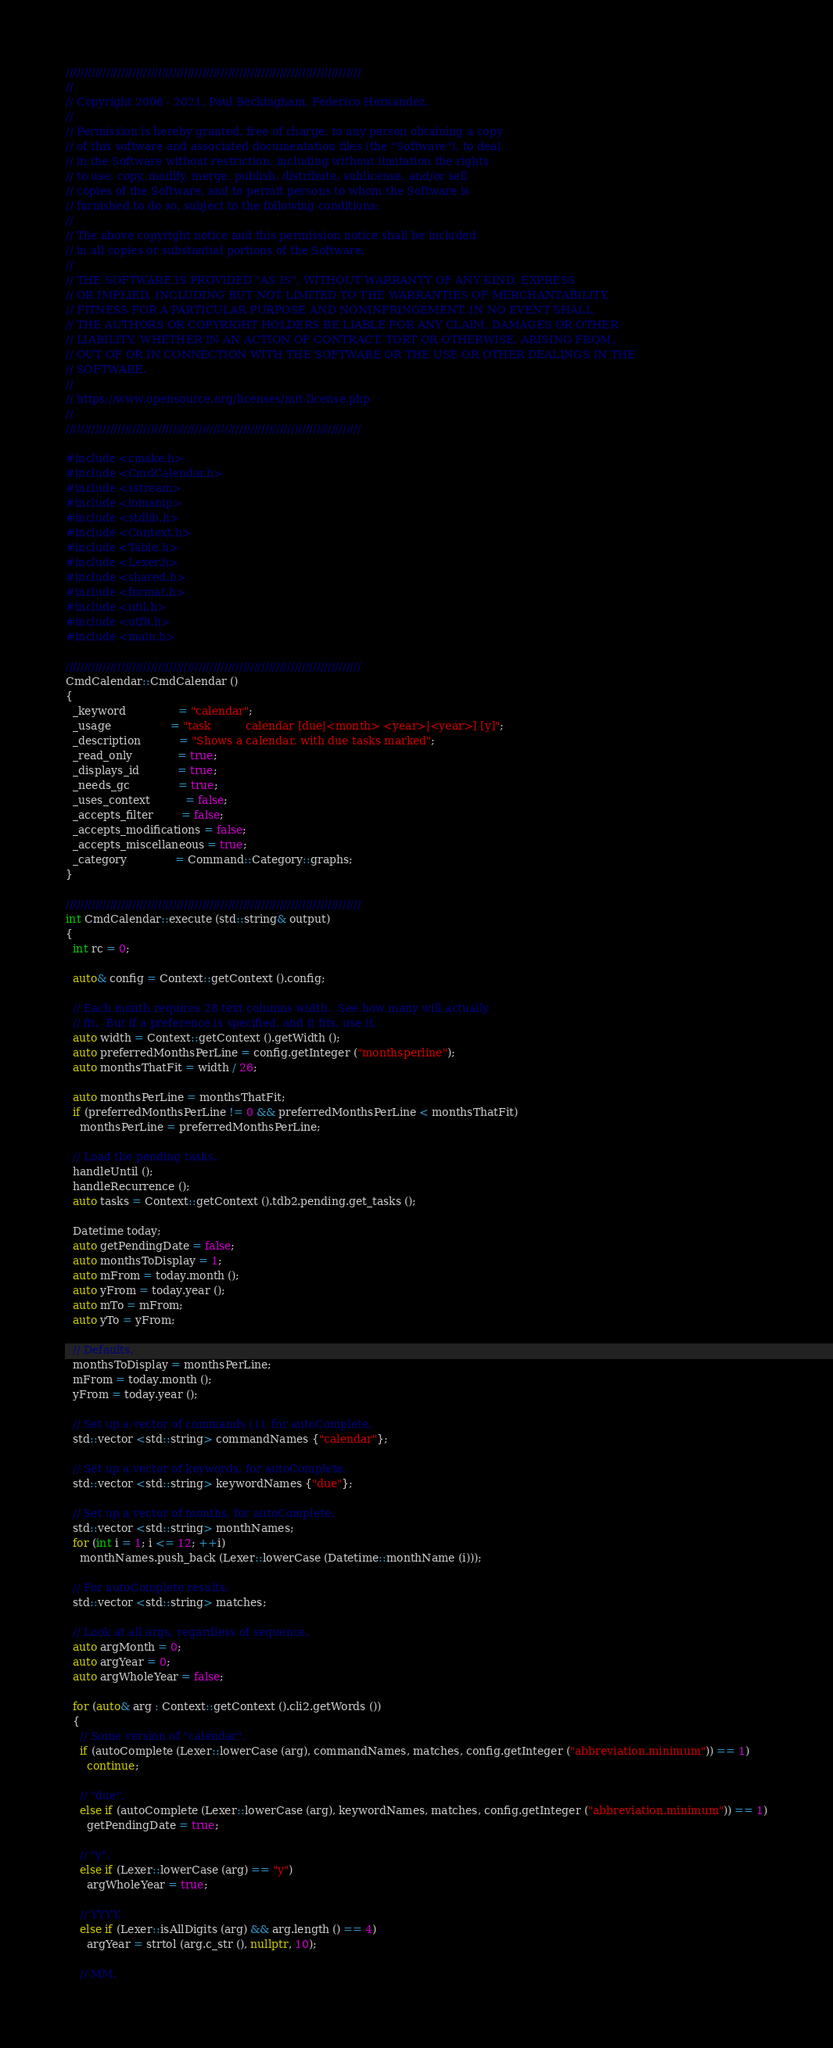Convert code to text. <code><loc_0><loc_0><loc_500><loc_500><_C++_>////////////////////////////////////////////////////////////////////////////////
//
// Copyright 2006 - 2021, Paul Beckingham, Federico Hernandez.
//
// Permission is hereby granted, free of charge, to any person obtaining a copy
// of this software and associated documentation files (the "Software"), to deal
// in the Software without restriction, including without limitation the rights
// to use, copy, modify, merge, publish, distribute, sublicense, and/or sell
// copies of the Software, and to permit persons to whom the Software is
// furnished to do so, subject to the following conditions:
//
// The above copyright notice and this permission notice shall be included
// in all copies or substantial portions of the Software.
//
// THE SOFTWARE IS PROVIDED "AS IS", WITHOUT WARRANTY OF ANY KIND, EXPRESS
// OR IMPLIED, INCLUDING BUT NOT LIMITED TO THE WARRANTIES OF MERCHANTABILITY,
// FITNESS FOR A PARTICULAR PURPOSE AND NONINFRINGEMENT. IN NO EVENT SHALL
// THE AUTHORS OR COPYRIGHT HOLDERS BE LIABLE FOR ANY CLAIM, DAMAGES OR OTHER
// LIABILITY, WHETHER IN AN ACTION OF CONTRACT, TORT OR OTHERWISE, ARISING FROM,
// OUT OF OR IN CONNECTION WITH THE SOFTWARE OR THE USE OR OTHER DEALINGS IN THE
// SOFTWARE.
//
// https://www.opensource.org/licenses/mit-license.php
//
////////////////////////////////////////////////////////////////////////////////

#include <cmake.h>
#include <CmdCalendar.h>
#include <sstream>
#include <iomanip>
#include <stdlib.h>
#include <Context.h>
#include <Table.h>
#include <Lexer.h>
#include <shared.h>
#include <format.h>
#include <util.h>
#include <utf8.h>
#include <main.h>

////////////////////////////////////////////////////////////////////////////////
CmdCalendar::CmdCalendar ()
{
  _keyword               = "calendar";
  _usage                 = "task          calendar [due|<month> <year>|<year>] [y]";
  _description           = "Shows a calendar, with due tasks marked";
  _read_only             = true;
  _displays_id           = true;
  _needs_gc              = true;
  _uses_context          = false;
  _accepts_filter        = false;
  _accepts_modifications = false;
  _accepts_miscellaneous = true;
  _category              = Command::Category::graphs;
}

////////////////////////////////////////////////////////////////////////////////
int CmdCalendar::execute (std::string& output)
{
  int rc = 0;

  auto& config = Context::getContext ().config;

  // Each month requires 28 text columns width.  See how many will actually
  // fit.  But if a preference is specified, and it fits, use it.
  auto width = Context::getContext ().getWidth ();
  auto preferredMonthsPerLine = config.getInteger ("monthsperline");
  auto monthsThatFit = width / 26;

  auto monthsPerLine = monthsThatFit;
  if (preferredMonthsPerLine != 0 && preferredMonthsPerLine < monthsThatFit)
    monthsPerLine = preferredMonthsPerLine;

  // Load the pending tasks.
  handleUntil ();
  handleRecurrence ();
  auto tasks = Context::getContext ().tdb2.pending.get_tasks ();

  Datetime today;
  auto getPendingDate = false;
  auto monthsToDisplay = 1;
  auto mFrom = today.month ();
  auto yFrom = today.year ();
  auto mTo = mFrom;
  auto yTo = yFrom;

  // Defaults.
  monthsToDisplay = monthsPerLine;
  mFrom = today.month ();
  yFrom = today.year ();

  // Set up a vector of commands (1), for autoComplete.
  std::vector <std::string> commandNames {"calendar"};

  // Set up a vector of keywords, for autoComplete.
  std::vector <std::string> keywordNames {"due"};

  // Set up a vector of months, for autoComplete.
  std::vector <std::string> monthNames;
  for (int i = 1; i <= 12; ++i)
    monthNames.push_back (Lexer::lowerCase (Datetime::monthName (i)));

  // For autoComplete results.
  std::vector <std::string> matches;

  // Look at all args, regardless of sequence.
  auto argMonth = 0;
  auto argYear = 0;
  auto argWholeYear = false;

  for (auto& arg : Context::getContext ().cli2.getWords ())
  {
    // Some version of "calendar".
    if (autoComplete (Lexer::lowerCase (arg), commandNames, matches, config.getInteger ("abbreviation.minimum")) == 1)
      continue;

    // "due".
    else if (autoComplete (Lexer::lowerCase (arg), keywordNames, matches, config.getInteger ("abbreviation.minimum")) == 1)
      getPendingDate = true;

    // "y".
    else if (Lexer::lowerCase (arg) == "y")
      argWholeYear = true;

    // YYYY.
    else if (Lexer::isAllDigits (arg) && arg.length () == 4)
      argYear = strtol (arg.c_str (), nullptr, 10);

    // MM.</code> 